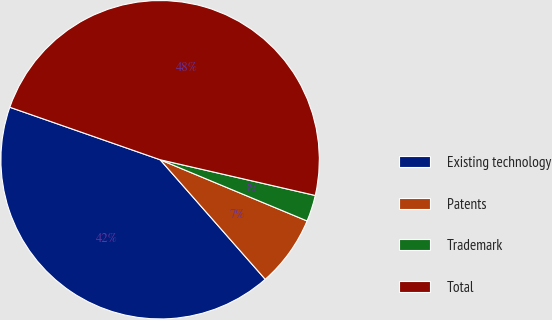<chart> <loc_0><loc_0><loc_500><loc_500><pie_chart><fcel>Existing technology<fcel>Patents<fcel>Trademark<fcel>Total<nl><fcel>41.83%<fcel>7.24%<fcel>2.68%<fcel>48.26%<nl></chart> 